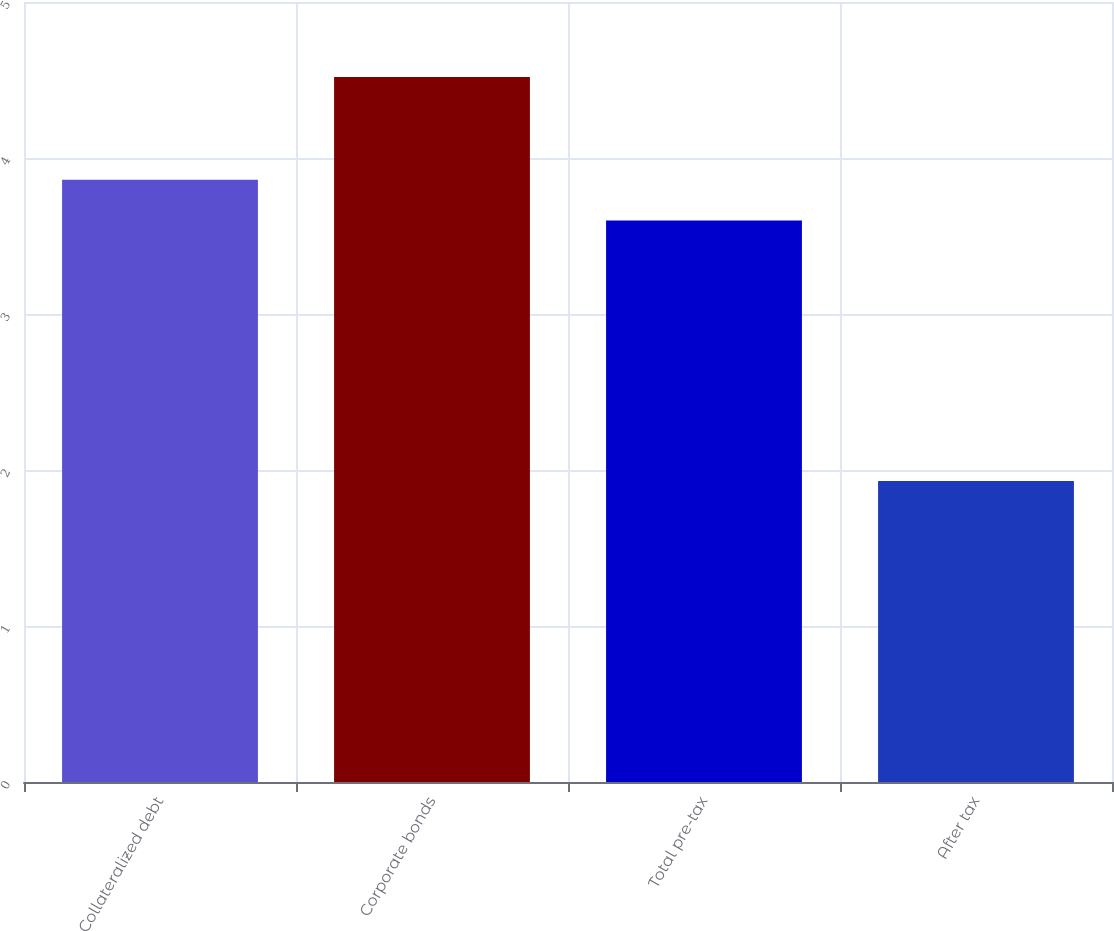<chart> <loc_0><loc_0><loc_500><loc_500><bar_chart><fcel>Collateralized debt<fcel>Corporate bonds<fcel>Total pre-tax<fcel>After tax<nl><fcel>3.86<fcel>4.52<fcel>3.6<fcel>1.93<nl></chart> 